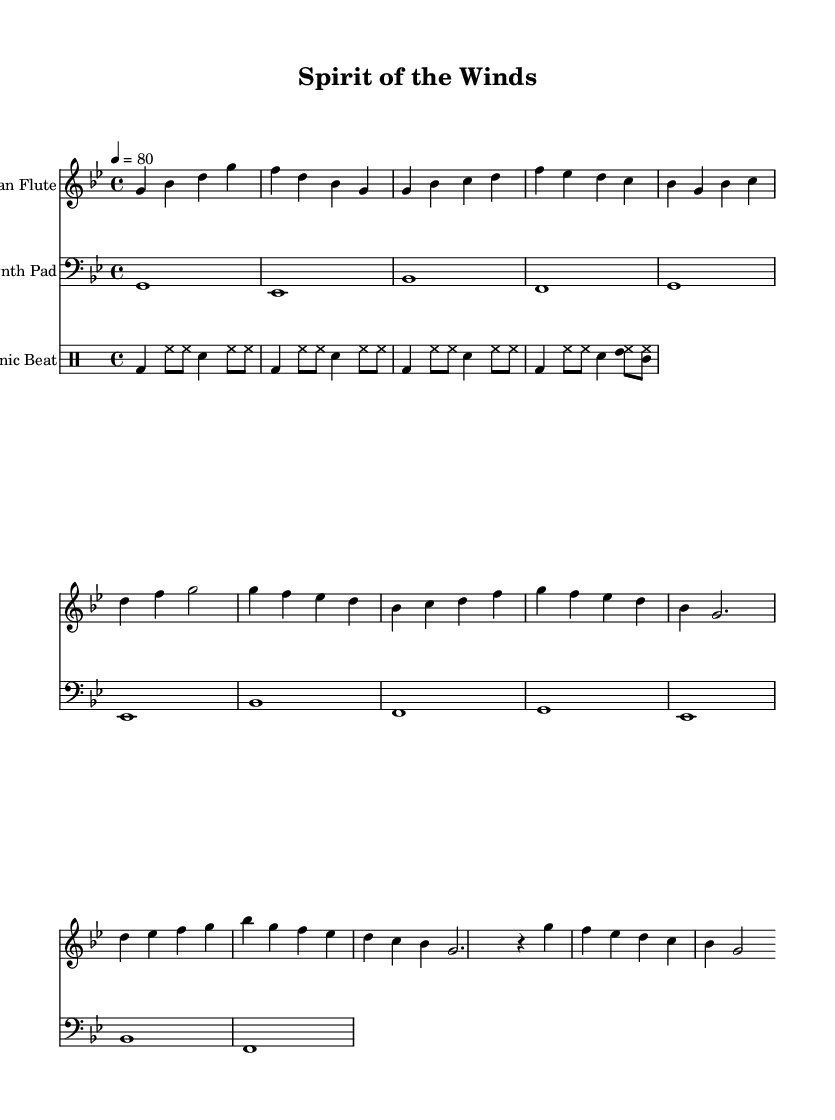What is the key signature of this music? The key signature is G minor, which has two flats (B♭ and E♭). It is indicated at the beginning of the staff.
Answer: G minor What is the time signature of this piece? The time signature is 4/4, indicating four beats per measure and a quarter note gets one beat. This is displayed at the beginning of the score.
Answer: 4/4 What is the tempo marking for this piece? The tempo marking is quarter note equals eighty beats per minute, which is indicated in the tempo directive at the start of the score.
Answer: 80 How many measures does the flute part contain? By counting the distinct groups of notes separated by bar lines in the flute part, we find there are 16 measures in total.
Answer: 16 What is the instrument used for the melodic line? The instrument designated for the melodic line is a Native American flute, as noted in the instrument name at the beginning of its staff.
Answer: Native American Flute Which instrument provides the electronic beats? The instrument specified for the electronic beats is the Electronic Beat, as indicated in the drum part of the score.
Answer: Electronic Beat What section of the music contains a bridge? The bridge section in the music is represented by the measures that contain the notes leading to a contrasting part, distinctly noted and built on the pitches D, E♭, F, G, and B♭.
Answer: Bridge 